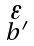Convert formula to latex. <formula><loc_0><loc_0><loc_500><loc_500>\begin{smallmatrix} \varepsilon \\ b ^ { \prime } \end{smallmatrix}</formula> 